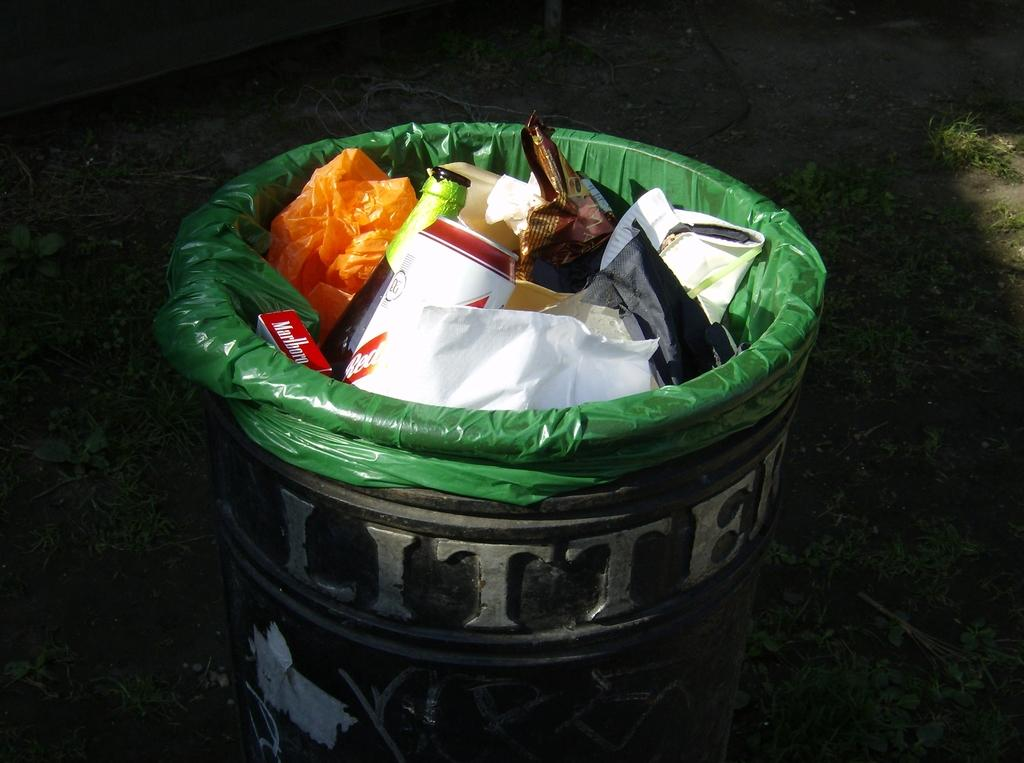<image>
Give a short and clear explanation of the subsequent image. A trash can with a green bag in it reads Litter. 